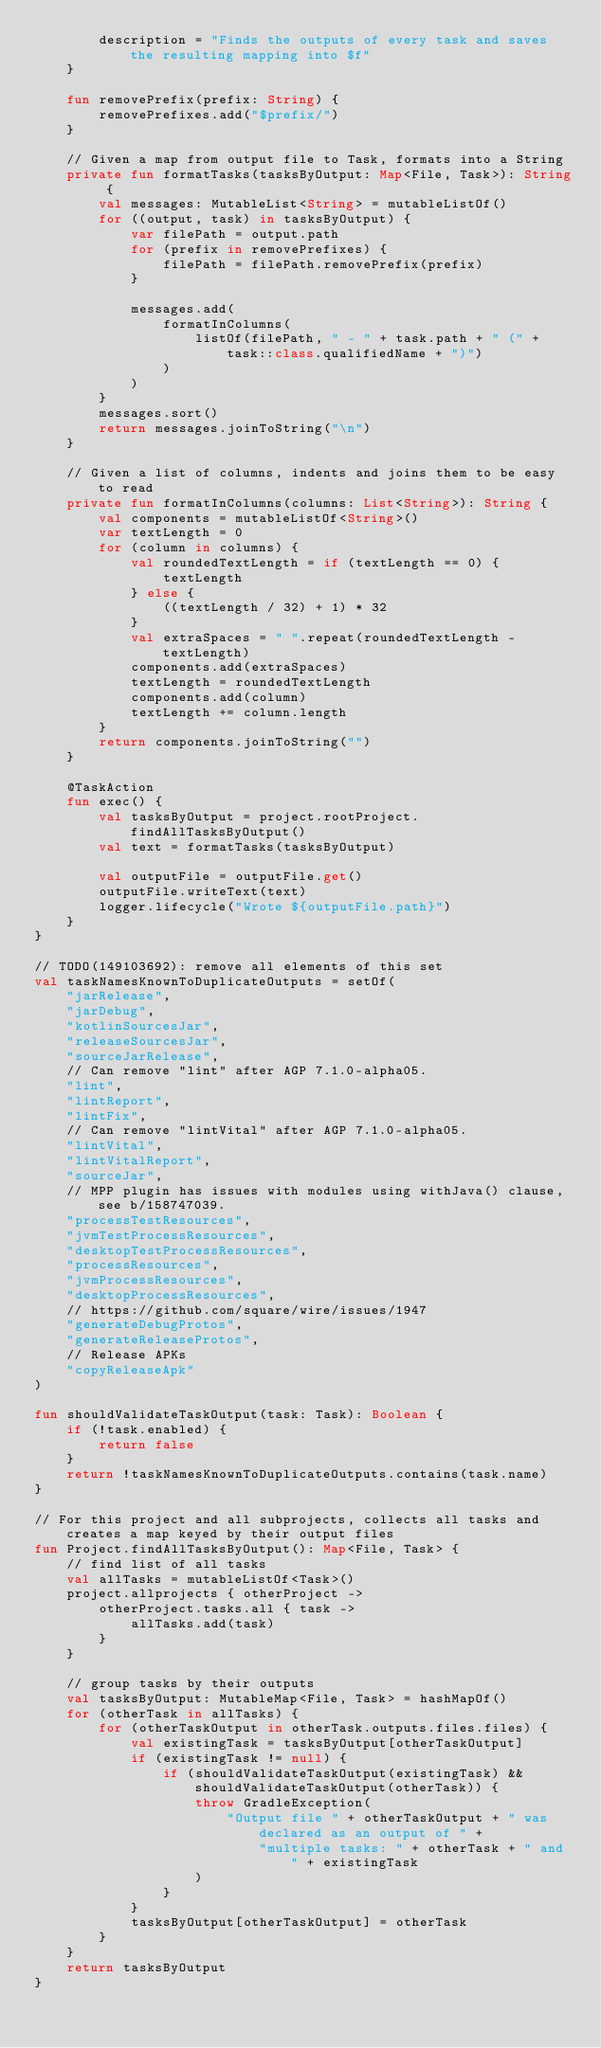<code> <loc_0><loc_0><loc_500><loc_500><_Kotlin_>        description = "Finds the outputs of every task and saves the resulting mapping into $f"
    }

    fun removePrefix(prefix: String) {
        removePrefixes.add("$prefix/")
    }

    // Given a map from output file to Task, formats into a String
    private fun formatTasks(tasksByOutput: Map<File, Task>): String {
        val messages: MutableList<String> = mutableListOf()
        for ((output, task) in tasksByOutput) {
            var filePath = output.path
            for (prefix in removePrefixes) {
                filePath = filePath.removePrefix(prefix)
            }

            messages.add(
                formatInColumns(
                    listOf(filePath, " - " + task.path + " (" + task::class.qualifiedName + ")")
                )
            )
        }
        messages.sort()
        return messages.joinToString("\n")
    }

    // Given a list of columns, indents and joins them to be easy to read
    private fun formatInColumns(columns: List<String>): String {
        val components = mutableListOf<String>()
        var textLength = 0
        for (column in columns) {
            val roundedTextLength = if (textLength == 0) {
                textLength
            } else {
                ((textLength / 32) + 1) * 32
            }
            val extraSpaces = " ".repeat(roundedTextLength - textLength)
            components.add(extraSpaces)
            textLength = roundedTextLength
            components.add(column)
            textLength += column.length
        }
        return components.joinToString("")
    }

    @TaskAction
    fun exec() {
        val tasksByOutput = project.rootProject.findAllTasksByOutput()
        val text = formatTasks(tasksByOutput)

        val outputFile = outputFile.get()
        outputFile.writeText(text)
        logger.lifecycle("Wrote ${outputFile.path}")
    }
}

// TODO(149103692): remove all elements of this set
val taskNamesKnownToDuplicateOutputs = setOf(
    "jarRelease",
    "jarDebug",
    "kotlinSourcesJar",
    "releaseSourcesJar",
    "sourceJarRelease",
    // Can remove "lint" after AGP 7.1.0-alpha05.
    "lint",
    "lintReport",
    "lintFix",
    // Can remove "lintVital" after AGP 7.1.0-alpha05.
    "lintVital",
    "lintVitalReport",
    "sourceJar",
    // MPP plugin has issues with modules using withJava() clause, see b/158747039.
    "processTestResources",
    "jvmTestProcessResources",
    "desktopTestProcessResources",
    "processResources",
    "jvmProcessResources",
    "desktopProcessResources",
    // https://github.com/square/wire/issues/1947
    "generateDebugProtos",
    "generateReleaseProtos",
    // Release APKs
    "copyReleaseApk"
)

fun shouldValidateTaskOutput(task: Task): Boolean {
    if (!task.enabled) {
        return false
    }
    return !taskNamesKnownToDuplicateOutputs.contains(task.name)
}

// For this project and all subprojects, collects all tasks and creates a map keyed by their output files
fun Project.findAllTasksByOutput(): Map<File, Task> {
    // find list of all tasks
    val allTasks = mutableListOf<Task>()
    project.allprojects { otherProject ->
        otherProject.tasks.all { task ->
            allTasks.add(task)
        }
    }

    // group tasks by their outputs
    val tasksByOutput: MutableMap<File, Task> = hashMapOf()
    for (otherTask in allTasks) {
        for (otherTaskOutput in otherTask.outputs.files.files) {
            val existingTask = tasksByOutput[otherTaskOutput]
            if (existingTask != null) {
                if (shouldValidateTaskOutput(existingTask) && shouldValidateTaskOutput(otherTask)) {
                    throw GradleException(
                        "Output file " + otherTaskOutput + " was declared as an output of " +
                            "multiple tasks: " + otherTask + " and " + existingTask
                    )
                }
            }
            tasksByOutput[otherTaskOutput] = otherTask
        }
    }
    return tasksByOutput
}
</code> 